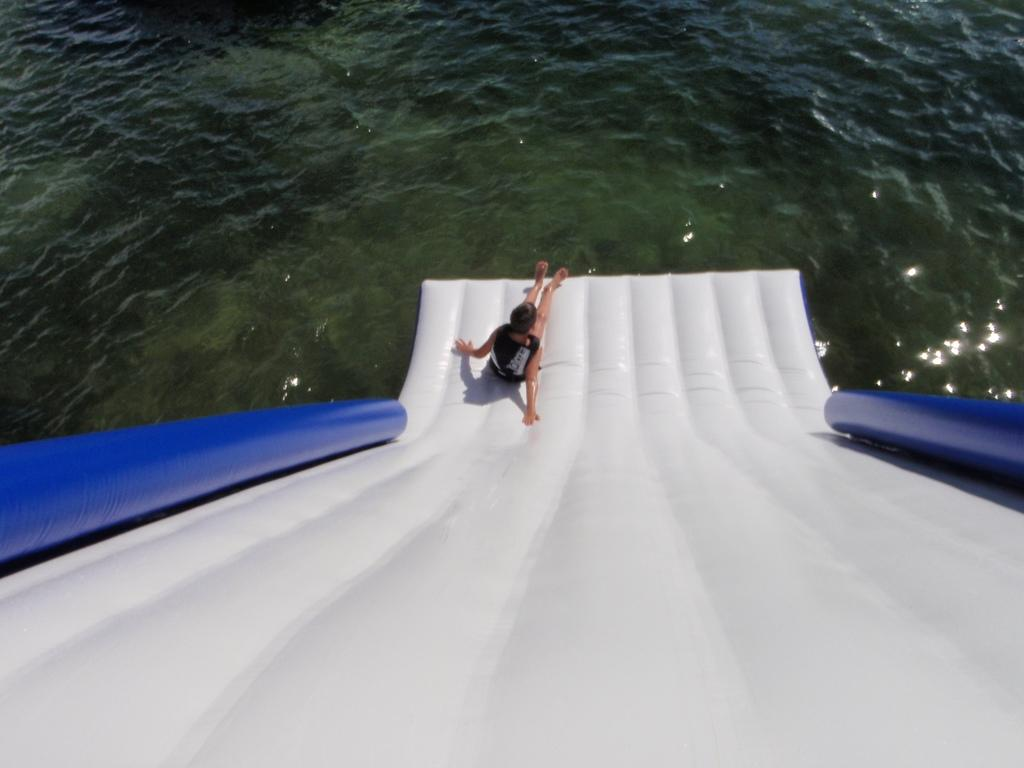What is the main feature in the foreground of the image? There is a water slide in the foreground of the image. Is there anyone using the water slide? Yes, a person is on the water slide. What can be seen in the background of the image? There is a water body visible in the background of the image. What type of magic is being performed by the person on the water slide? There is no magic being performed in the image; it simply shows a person on a water slide. Is there any grass visible in the image? The provided facts do not mention grass, so we cannot determine if it is present in the image. 